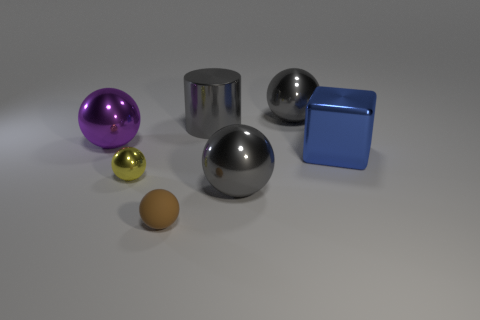What number of metallic things have the same color as the rubber ball?
Your answer should be very brief. 0. What number of things are to the right of the brown thing and in front of the cube?
Your response must be concise. 1. What is the large gray sphere that is on the right side of the big gray metallic object in front of the big cylinder made of?
Give a very brief answer. Metal. Are there any big blocks made of the same material as the gray cylinder?
Give a very brief answer. Yes. There is a cube that is the same size as the purple metallic sphere; what is it made of?
Offer a very short reply. Metal. There is a ball in front of the gray sphere in front of the large gray shiny ball that is behind the large blue metallic cube; how big is it?
Provide a succinct answer. Small. There is a big gray metal sphere that is in front of the large blue cube; is there a yellow sphere in front of it?
Provide a short and direct response. No. There is a large purple metal thing; is it the same shape as the large object that is in front of the blue object?
Make the answer very short. Yes. There is a tiny thing that is behind the rubber ball; what color is it?
Offer a terse response. Yellow. There is a gray shiny object to the right of the gray object that is in front of the large block; what is its size?
Provide a short and direct response. Large. 